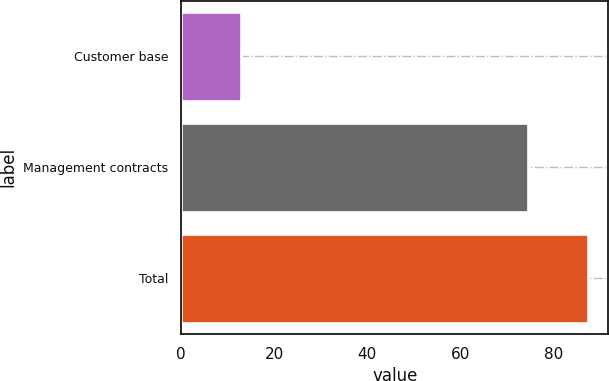Convert chart to OTSL. <chart><loc_0><loc_0><loc_500><loc_500><bar_chart><fcel>Customer base<fcel>Management contracts<fcel>Total<nl><fcel>12.9<fcel>74.6<fcel>87.5<nl></chart> 